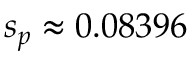<formula> <loc_0><loc_0><loc_500><loc_500>s _ { p } \approx 0 . 0 8 3 9 6</formula> 